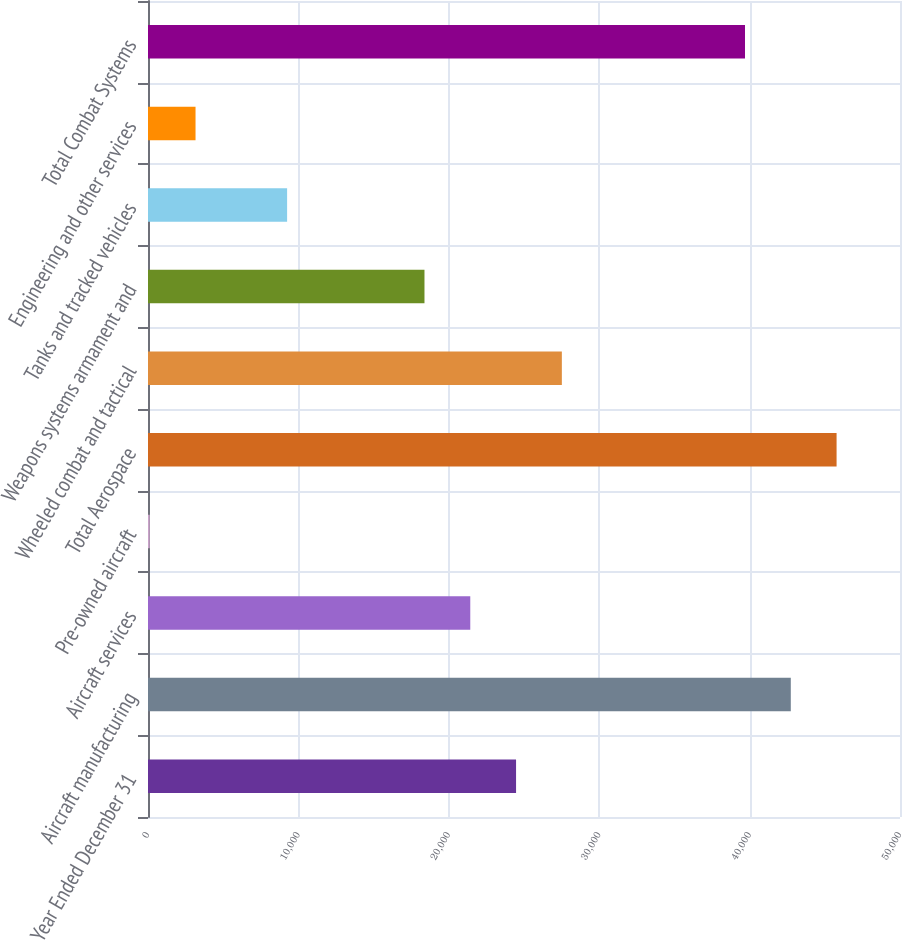<chart> <loc_0><loc_0><loc_500><loc_500><bar_chart><fcel>Year Ended December 31<fcel>Aircraft manufacturing<fcel>Aircraft services<fcel>Pre-owned aircraft<fcel>Total Aerospace<fcel>Wheeled combat and tactical<fcel>Weapons systems armament and<fcel>Tanks and tracked vehicles<fcel>Engineering and other services<fcel>Total Combat Systems<nl><fcel>24472<fcel>42739<fcel>21427.5<fcel>116<fcel>45783.5<fcel>27516.5<fcel>18383<fcel>9249.5<fcel>3160.5<fcel>39694.5<nl></chart> 